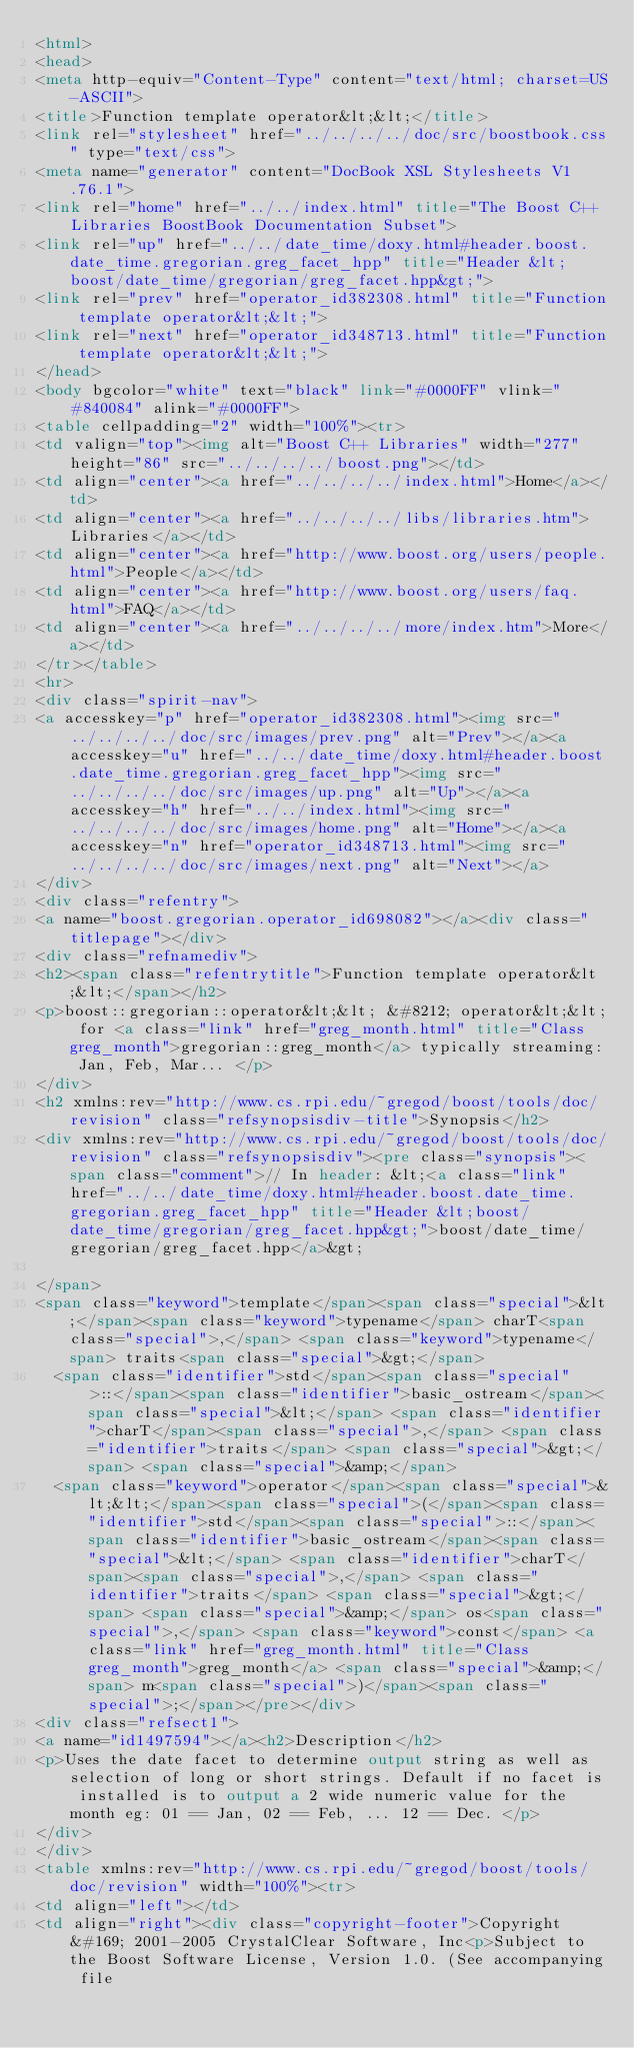<code> <loc_0><loc_0><loc_500><loc_500><_HTML_><html>
<head>
<meta http-equiv="Content-Type" content="text/html; charset=US-ASCII">
<title>Function template operator&lt;&lt;</title>
<link rel="stylesheet" href="../../../../doc/src/boostbook.css" type="text/css">
<meta name="generator" content="DocBook XSL Stylesheets V1.76.1">
<link rel="home" href="../../index.html" title="The Boost C++ Libraries BoostBook Documentation Subset">
<link rel="up" href="../../date_time/doxy.html#header.boost.date_time.gregorian.greg_facet_hpp" title="Header &lt;boost/date_time/gregorian/greg_facet.hpp&gt;">
<link rel="prev" href="operator_id382308.html" title="Function template operator&lt;&lt;">
<link rel="next" href="operator_id348713.html" title="Function template operator&lt;&lt;">
</head>
<body bgcolor="white" text="black" link="#0000FF" vlink="#840084" alink="#0000FF">
<table cellpadding="2" width="100%"><tr>
<td valign="top"><img alt="Boost C++ Libraries" width="277" height="86" src="../../../../boost.png"></td>
<td align="center"><a href="../../../../index.html">Home</a></td>
<td align="center"><a href="../../../../libs/libraries.htm">Libraries</a></td>
<td align="center"><a href="http://www.boost.org/users/people.html">People</a></td>
<td align="center"><a href="http://www.boost.org/users/faq.html">FAQ</a></td>
<td align="center"><a href="../../../../more/index.htm">More</a></td>
</tr></table>
<hr>
<div class="spirit-nav">
<a accesskey="p" href="operator_id382308.html"><img src="../../../../doc/src/images/prev.png" alt="Prev"></a><a accesskey="u" href="../../date_time/doxy.html#header.boost.date_time.gregorian.greg_facet_hpp"><img src="../../../../doc/src/images/up.png" alt="Up"></a><a accesskey="h" href="../../index.html"><img src="../../../../doc/src/images/home.png" alt="Home"></a><a accesskey="n" href="operator_id348713.html"><img src="../../../../doc/src/images/next.png" alt="Next"></a>
</div>
<div class="refentry">
<a name="boost.gregorian.operator_id698082"></a><div class="titlepage"></div>
<div class="refnamediv">
<h2><span class="refentrytitle">Function template operator&lt;&lt;</span></h2>
<p>boost::gregorian::operator&lt;&lt; &#8212; operator&lt;&lt; for <a class="link" href="greg_month.html" title="Class greg_month">gregorian::greg_month</a> typically streaming: Jan, Feb, Mar... </p>
</div>
<h2 xmlns:rev="http://www.cs.rpi.edu/~gregod/boost/tools/doc/revision" class="refsynopsisdiv-title">Synopsis</h2>
<div xmlns:rev="http://www.cs.rpi.edu/~gregod/boost/tools/doc/revision" class="refsynopsisdiv"><pre class="synopsis"><span class="comment">// In header: &lt;<a class="link" href="../../date_time/doxy.html#header.boost.date_time.gregorian.greg_facet_hpp" title="Header &lt;boost/date_time/gregorian/greg_facet.hpp&gt;">boost/date_time/gregorian/greg_facet.hpp</a>&gt;

</span>
<span class="keyword">template</span><span class="special">&lt;</span><span class="keyword">typename</span> charT<span class="special">,</span> <span class="keyword">typename</span> traits<span class="special">&gt;</span> 
  <span class="identifier">std</span><span class="special">::</span><span class="identifier">basic_ostream</span><span class="special">&lt;</span> <span class="identifier">charT</span><span class="special">,</span> <span class="identifier">traits</span> <span class="special">&gt;</span> <span class="special">&amp;</span> 
  <span class="keyword">operator</span><span class="special">&lt;&lt;</span><span class="special">(</span><span class="identifier">std</span><span class="special">::</span><span class="identifier">basic_ostream</span><span class="special">&lt;</span> <span class="identifier">charT</span><span class="special">,</span> <span class="identifier">traits</span> <span class="special">&gt;</span> <span class="special">&amp;</span> os<span class="special">,</span> <span class="keyword">const</span> <a class="link" href="greg_month.html" title="Class greg_month">greg_month</a> <span class="special">&amp;</span> m<span class="special">)</span><span class="special">;</span></pre></div>
<div class="refsect1">
<a name="id1497594"></a><h2>Description</h2>
<p>Uses the date facet to determine output string as well as selection of long or short strings. Default if no facet is installed is to output a 2 wide numeric value for the month eg: 01 == Jan, 02 == Feb, ... 12 == Dec. </p>
</div>
</div>
<table xmlns:rev="http://www.cs.rpi.edu/~gregod/boost/tools/doc/revision" width="100%"><tr>
<td align="left"></td>
<td align="right"><div class="copyright-footer">Copyright &#169; 2001-2005 CrystalClear Software, Inc<p>Subject to the Boost Software License, Version 1.0. (See accompanying file</code> 